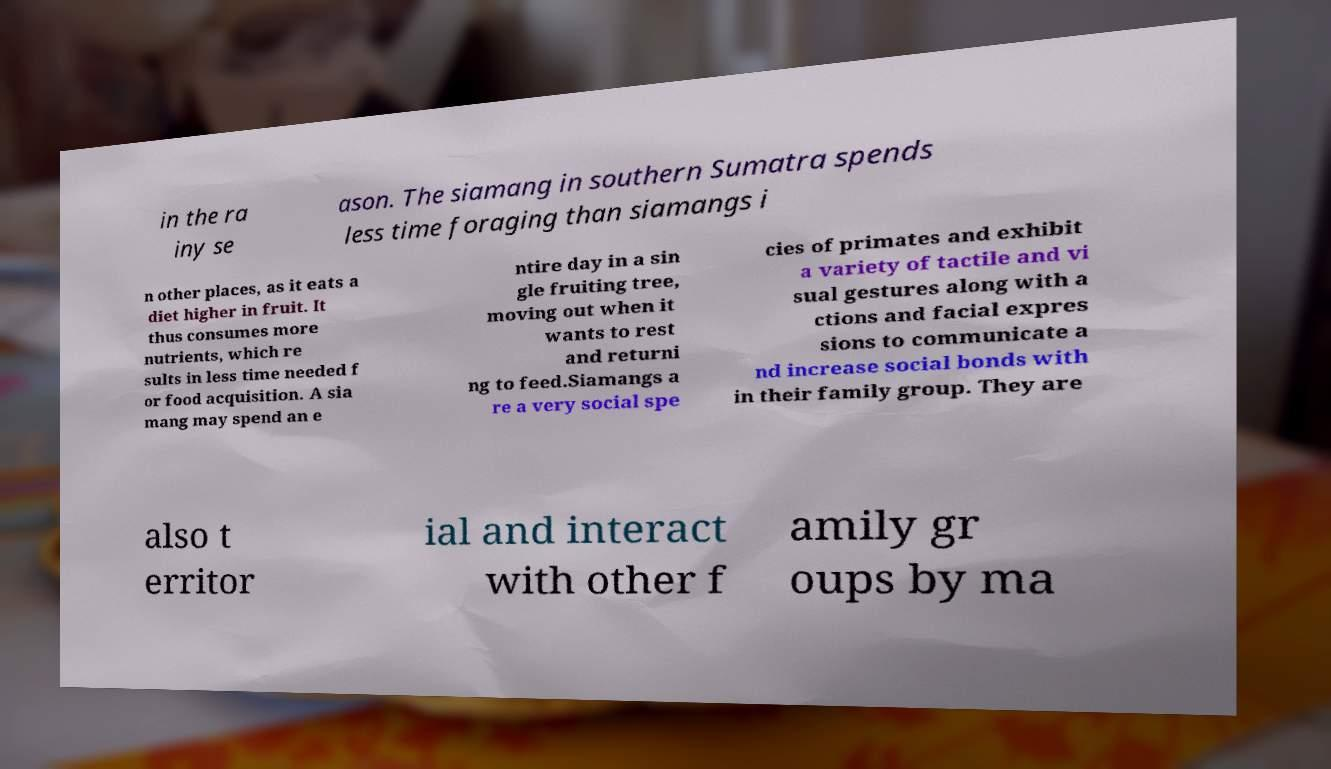For documentation purposes, I need the text within this image transcribed. Could you provide that? in the ra iny se ason. The siamang in southern Sumatra spends less time foraging than siamangs i n other places, as it eats a diet higher in fruit. It thus consumes more nutrients, which re sults in less time needed f or food acquisition. A sia mang may spend an e ntire day in a sin gle fruiting tree, moving out when it wants to rest and returni ng to feed.Siamangs a re a very social spe cies of primates and exhibit a variety of tactile and vi sual gestures along with a ctions and facial expres sions to communicate a nd increase social bonds with in their family group. They are also t erritor ial and interact with other f amily gr oups by ma 